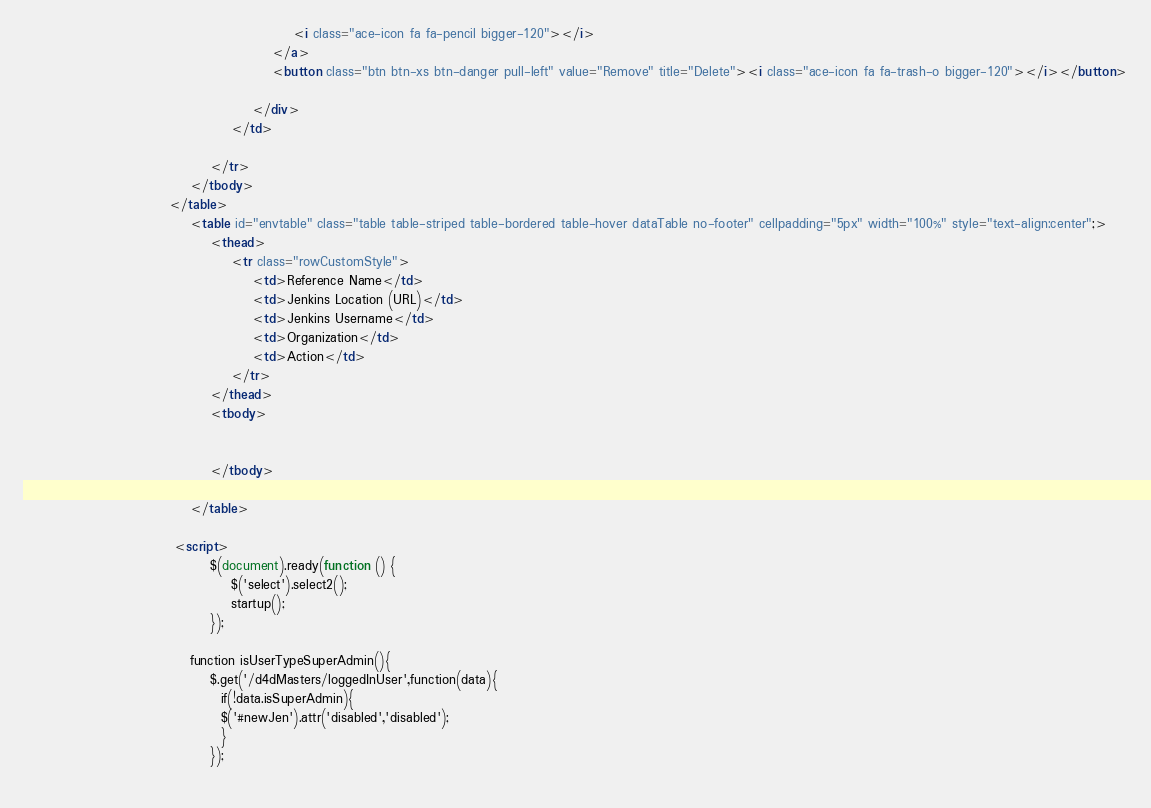<code> <loc_0><loc_0><loc_500><loc_500><_HTML_>                                                    <i class="ace-icon fa fa-pencil bigger-120"></i>
                                                </a>
                                                <button class="btn btn-xs btn-danger pull-left" value="Remove" title="Delete"><i class="ace-icon fa fa-trash-o bigger-120"></i></button>
                                                
                                            </div>
                                        </td>

                                    </tr>
                                </tbody>
                            </table>
                                <table id="envtable" class="table table-striped table-bordered table-hover dataTable no-footer" cellpadding="5px" width="100%" style="text-align:center";>
                                    <thead>
                                        <tr class="rowCustomStyle">
                                            <td>Reference Name</td>
                                            <td>Jenkins Location (URL)</td>
                                            <td>Jenkins Username</td>
                                            <td>Organization</td>
                                            <td>Action</td>
                                        </tr>
                                    </thead>
                                    <tbody>
                                        
                                       
                                    </tbody>
                                    
                                </table> 
                            
                             <script>
                                    $(document).ready(function () {
                                        $('select').select2();
                                        startup(); 
                                    });

                                function isUserTypeSuperAdmin(){
                                    $.get('/d4dMasters/loggedInUser',function(data){
                                      if(!data.isSuperAdmin){
                                      $('#newJen').attr('disabled','disabled');
                                      }
                                    });
                                   </code> 